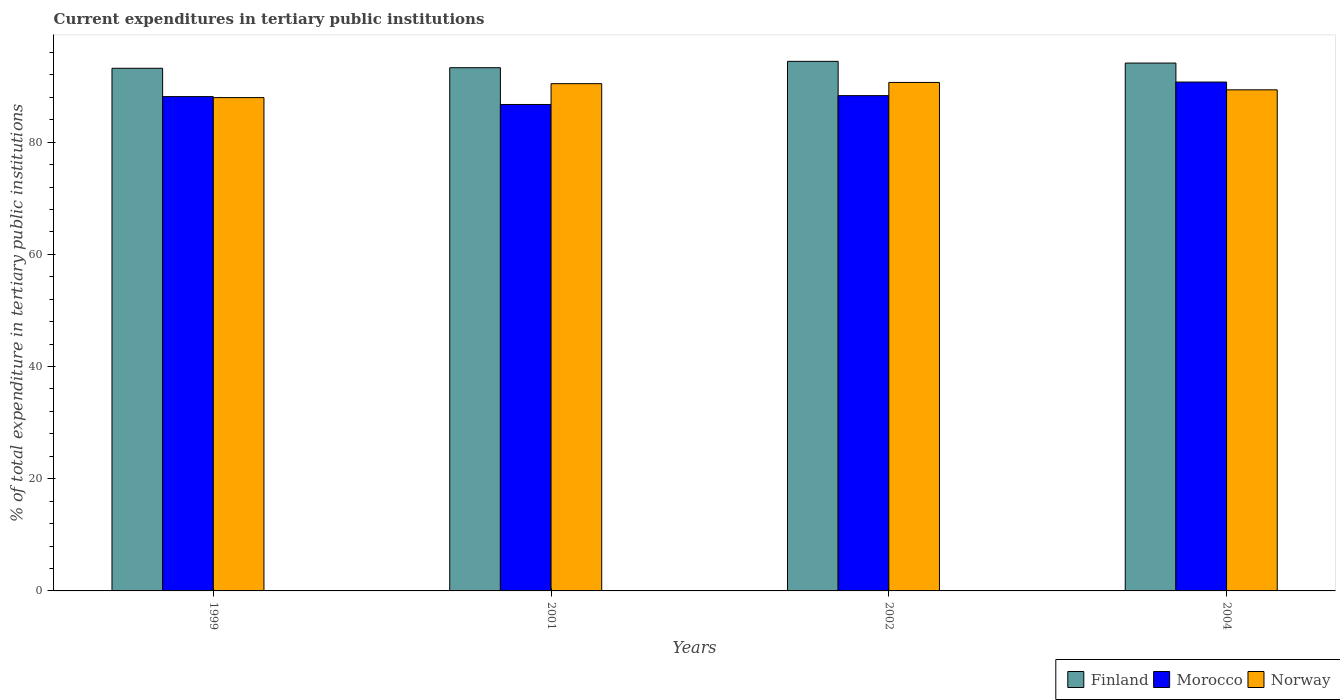How many different coloured bars are there?
Provide a succinct answer. 3. How many groups of bars are there?
Your answer should be compact. 4. Are the number of bars per tick equal to the number of legend labels?
Make the answer very short. Yes. How many bars are there on the 1st tick from the left?
Make the answer very short. 3. How many bars are there on the 2nd tick from the right?
Keep it short and to the point. 3. What is the label of the 2nd group of bars from the left?
Ensure brevity in your answer.  2001. What is the current expenditures in tertiary public institutions in Finland in 2002?
Provide a short and direct response. 94.4. Across all years, what is the maximum current expenditures in tertiary public institutions in Finland?
Ensure brevity in your answer.  94.4. Across all years, what is the minimum current expenditures in tertiary public institutions in Norway?
Provide a succinct answer. 87.94. In which year was the current expenditures in tertiary public institutions in Finland maximum?
Your answer should be very brief. 2002. What is the total current expenditures in tertiary public institutions in Finland in the graph?
Your answer should be very brief. 374.93. What is the difference between the current expenditures in tertiary public institutions in Finland in 1999 and that in 2004?
Provide a succinct answer. -0.93. What is the difference between the current expenditures in tertiary public institutions in Finland in 2002 and the current expenditures in tertiary public institutions in Norway in 1999?
Offer a very short reply. 6.46. What is the average current expenditures in tertiary public institutions in Finland per year?
Ensure brevity in your answer.  93.73. In the year 1999, what is the difference between the current expenditures in tertiary public institutions in Finland and current expenditures in tertiary public institutions in Morocco?
Provide a succinct answer. 5.05. What is the ratio of the current expenditures in tertiary public institutions in Finland in 2001 to that in 2004?
Provide a succinct answer. 0.99. Is the difference between the current expenditures in tertiary public institutions in Finland in 2002 and 2004 greater than the difference between the current expenditures in tertiary public institutions in Morocco in 2002 and 2004?
Offer a terse response. Yes. What is the difference between the highest and the second highest current expenditures in tertiary public institutions in Morocco?
Keep it short and to the point. 2.42. What is the difference between the highest and the lowest current expenditures in tertiary public institutions in Finland?
Your answer should be very brief. 1.23. Is the sum of the current expenditures in tertiary public institutions in Morocco in 1999 and 2001 greater than the maximum current expenditures in tertiary public institutions in Finland across all years?
Provide a short and direct response. Yes. Is it the case that in every year, the sum of the current expenditures in tertiary public institutions in Finland and current expenditures in tertiary public institutions in Norway is greater than the current expenditures in tertiary public institutions in Morocco?
Provide a short and direct response. Yes. How many bars are there?
Give a very brief answer. 12. Are all the bars in the graph horizontal?
Provide a succinct answer. No. What is the difference between two consecutive major ticks on the Y-axis?
Offer a terse response. 20. Are the values on the major ticks of Y-axis written in scientific E-notation?
Ensure brevity in your answer.  No. How many legend labels are there?
Provide a short and direct response. 3. What is the title of the graph?
Provide a short and direct response. Current expenditures in tertiary public institutions. What is the label or title of the X-axis?
Provide a succinct answer. Years. What is the label or title of the Y-axis?
Your answer should be very brief. % of total expenditure in tertiary public institutions. What is the % of total expenditure in tertiary public institutions of Finland in 1999?
Your answer should be compact. 93.17. What is the % of total expenditure in tertiary public institutions of Morocco in 1999?
Make the answer very short. 88.11. What is the % of total expenditure in tertiary public institutions of Norway in 1999?
Give a very brief answer. 87.94. What is the % of total expenditure in tertiary public institutions of Finland in 2001?
Provide a short and direct response. 93.27. What is the % of total expenditure in tertiary public institutions in Morocco in 2001?
Offer a terse response. 86.71. What is the % of total expenditure in tertiary public institutions of Norway in 2001?
Ensure brevity in your answer.  90.42. What is the % of total expenditure in tertiary public institutions in Finland in 2002?
Provide a short and direct response. 94.4. What is the % of total expenditure in tertiary public institutions of Morocco in 2002?
Offer a terse response. 88.29. What is the % of total expenditure in tertiary public institutions of Norway in 2002?
Your answer should be very brief. 90.64. What is the % of total expenditure in tertiary public institutions in Finland in 2004?
Your answer should be very brief. 94.09. What is the % of total expenditure in tertiary public institutions of Morocco in 2004?
Provide a succinct answer. 90.71. What is the % of total expenditure in tertiary public institutions of Norway in 2004?
Your response must be concise. 89.32. Across all years, what is the maximum % of total expenditure in tertiary public institutions of Finland?
Make the answer very short. 94.4. Across all years, what is the maximum % of total expenditure in tertiary public institutions of Morocco?
Keep it short and to the point. 90.71. Across all years, what is the maximum % of total expenditure in tertiary public institutions in Norway?
Your answer should be compact. 90.64. Across all years, what is the minimum % of total expenditure in tertiary public institutions in Finland?
Provide a succinct answer. 93.17. Across all years, what is the minimum % of total expenditure in tertiary public institutions of Morocco?
Your answer should be compact. 86.71. Across all years, what is the minimum % of total expenditure in tertiary public institutions of Norway?
Provide a short and direct response. 87.94. What is the total % of total expenditure in tertiary public institutions of Finland in the graph?
Your answer should be very brief. 374.93. What is the total % of total expenditure in tertiary public institutions of Morocco in the graph?
Your answer should be very brief. 353.83. What is the total % of total expenditure in tertiary public institutions of Norway in the graph?
Keep it short and to the point. 358.32. What is the difference between the % of total expenditure in tertiary public institutions of Finland in 1999 and that in 2001?
Offer a terse response. -0.1. What is the difference between the % of total expenditure in tertiary public institutions in Morocco in 1999 and that in 2001?
Your response must be concise. 1.4. What is the difference between the % of total expenditure in tertiary public institutions in Norway in 1999 and that in 2001?
Provide a short and direct response. -2.48. What is the difference between the % of total expenditure in tertiary public institutions of Finland in 1999 and that in 2002?
Your response must be concise. -1.23. What is the difference between the % of total expenditure in tertiary public institutions in Morocco in 1999 and that in 2002?
Offer a terse response. -0.17. What is the difference between the % of total expenditure in tertiary public institutions in Norway in 1999 and that in 2002?
Provide a succinct answer. -2.7. What is the difference between the % of total expenditure in tertiary public institutions of Finland in 1999 and that in 2004?
Offer a terse response. -0.93. What is the difference between the % of total expenditure in tertiary public institutions of Morocco in 1999 and that in 2004?
Give a very brief answer. -2.6. What is the difference between the % of total expenditure in tertiary public institutions in Norway in 1999 and that in 2004?
Make the answer very short. -1.38. What is the difference between the % of total expenditure in tertiary public institutions of Finland in 2001 and that in 2002?
Make the answer very short. -1.13. What is the difference between the % of total expenditure in tertiary public institutions of Morocco in 2001 and that in 2002?
Your response must be concise. -1.57. What is the difference between the % of total expenditure in tertiary public institutions in Norway in 2001 and that in 2002?
Your response must be concise. -0.22. What is the difference between the % of total expenditure in tertiary public institutions of Finland in 2001 and that in 2004?
Your answer should be compact. -0.83. What is the difference between the % of total expenditure in tertiary public institutions in Morocco in 2001 and that in 2004?
Provide a succinct answer. -4. What is the difference between the % of total expenditure in tertiary public institutions in Norway in 2001 and that in 2004?
Your response must be concise. 1.1. What is the difference between the % of total expenditure in tertiary public institutions of Finland in 2002 and that in 2004?
Keep it short and to the point. 0.31. What is the difference between the % of total expenditure in tertiary public institutions of Morocco in 2002 and that in 2004?
Provide a succinct answer. -2.42. What is the difference between the % of total expenditure in tertiary public institutions of Norway in 2002 and that in 2004?
Provide a short and direct response. 1.32. What is the difference between the % of total expenditure in tertiary public institutions in Finland in 1999 and the % of total expenditure in tertiary public institutions in Morocco in 2001?
Provide a succinct answer. 6.45. What is the difference between the % of total expenditure in tertiary public institutions in Finland in 1999 and the % of total expenditure in tertiary public institutions in Norway in 2001?
Make the answer very short. 2.74. What is the difference between the % of total expenditure in tertiary public institutions in Morocco in 1999 and the % of total expenditure in tertiary public institutions in Norway in 2001?
Your answer should be compact. -2.31. What is the difference between the % of total expenditure in tertiary public institutions in Finland in 1999 and the % of total expenditure in tertiary public institutions in Morocco in 2002?
Offer a terse response. 4.88. What is the difference between the % of total expenditure in tertiary public institutions of Finland in 1999 and the % of total expenditure in tertiary public institutions of Norway in 2002?
Offer a very short reply. 2.52. What is the difference between the % of total expenditure in tertiary public institutions in Morocco in 1999 and the % of total expenditure in tertiary public institutions in Norway in 2002?
Offer a very short reply. -2.53. What is the difference between the % of total expenditure in tertiary public institutions of Finland in 1999 and the % of total expenditure in tertiary public institutions of Morocco in 2004?
Provide a succinct answer. 2.46. What is the difference between the % of total expenditure in tertiary public institutions of Finland in 1999 and the % of total expenditure in tertiary public institutions of Norway in 2004?
Your answer should be compact. 3.84. What is the difference between the % of total expenditure in tertiary public institutions of Morocco in 1999 and the % of total expenditure in tertiary public institutions of Norway in 2004?
Give a very brief answer. -1.21. What is the difference between the % of total expenditure in tertiary public institutions of Finland in 2001 and the % of total expenditure in tertiary public institutions of Morocco in 2002?
Keep it short and to the point. 4.98. What is the difference between the % of total expenditure in tertiary public institutions in Finland in 2001 and the % of total expenditure in tertiary public institutions in Norway in 2002?
Provide a succinct answer. 2.63. What is the difference between the % of total expenditure in tertiary public institutions of Morocco in 2001 and the % of total expenditure in tertiary public institutions of Norway in 2002?
Give a very brief answer. -3.93. What is the difference between the % of total expenditure in tertiary public institutions of Finland in 2001 and the % of total expenditure in tertiary public institutions of Morocco in 2004?
Ensure brevity in your answer.  2.56. What is the difference between the % of total expenditure in tertiary public institutions in Finland in 2001 and the % of total expenditure in tertiary public institutions in Norway in 2004?
Your answer should be very brief. 3.94. What is the difference between the % of total expenditure in tertiary public institutions in Morocco in 2001 and the % of total expenditure in tertiary public institutions in Norway in 2004?
Provide a short and direct response. -2.61. What is the difference between the % of total expenditure in tertiary public institutions in Finland in 2002 and the % of total expenditure in tertiary public institutions in Morocco in 2004?
Your response must be concise. 3.69. What is the difference between the % of total expenditure in tertiary public institutions of Finland in 2002 and the % of total expenditure in tertiary public institutions of Norway in 2004?
Your response must be concise. 5.08. What is the difference between the % of total expenditure in tertiary public institutions in Morocco in 2002 and the % of total expenditure in tertiary public institutions in Norway in 2004?
Your answer should be very brief. -1.03. What is the average % of total expenditure in tertiary public institutions of Finland per year?
Your answer should be compact. 93.73. What is the average % of total expenditure in tertiary public institutions of Morocco per year?
Ensure brevity in your answer.  88.46. What is the average % of total expenditure in tertiary public institutions of Norway per year?
Provide a short and direct response. 89.58. In the year 1999, what is the difference between the % of total expenditure in tertiary public institutions of Finland and % of total expenditure in tertiary public institutions of Morocco?
Your answer should be very brief. 5.05. In the year 1999, what is the difference between the % of total expenditure in tertiary public institutions of Finland and % of total expenditure in tertiary public institutions of Norway?
Your answer should be compact. 5.23. In the year 1999, what is the difference between the % of total expenditure in tertiary public institutions of Morocco and % of total expenditure in tertiary public institutions of Norway?
Your answer should be compact. 0.18. In the year 2001, what is the difference between the % of total expenditure in tertiary public institutions of Finland and % of total expenditure in tertiary public institutions of Morocco?
Offer a very short reply. 6.55. In the year 2001, what is the difference between the % of total expenditure in tertiary public institutions in Finland and % of total expenditure in tertiary public institutions in Norway?
Keep it short and to the point. 2.85. In the year 2001, what is the difference between the % of total expenditure in tertiary public institutions of Morocco and % of total expenditure in tertiary public institutions of Norway?
Give a very brief answer. -3.71. In the year 2002, what is the difference between the % of total expenditure in tertiary public institutions of Finland and % of total expenditure in tertiary public institutions of Morocco?
Give a very brief answer. 6.11. In the year 2002, what is the difference between the % of total expenditure in tertiary public institutions in Finland and % of total expenditure in tertiary public institutions in Norway?
Your answer should be compact. 3.76. In the year 2002, what is the difference between the % of total expenditure in tertiary public institutions of Morocco and % of total expenditure in tertiary public institutions of Norway?
Keep it short and to the point. -2.35. In the year 2004, what is the difference between the % of total expenditure in tertiary public institutions of Finland and % of total expenditure in tertiary public institutions of Morocco?
Provide a short and direct response. 3.39. In the year 2004, what is the difference between the % of total expenditure in tertiary public institutions of Finland and % of total expenditure in tertiary public institutions of Norway?
Provide a succinct answer. 4.77. In the year 2004, what is the difference between the % of total expenditure in tertiary public institutions of Morocco and % of total expenditure in tertiary public institutions of Norway?
Ensure brevity in your answer.  1.39. What is the ratio of the % of total expenditure in tertiary public institutions in Finland in 1999 to that in 2001?
Offer a very short reply. 1. What is the ratio of the % of total expenditure in tertiary public institutions of Morocco in 1999 to that in 2001?
Give a very brief answer. 1.02. What is the ratio of the % of total expenditure in tertiary public institutions in Norway in 1999 to that in 2001?
Make the answer very short. 0.97. What is the ratio of the % of total expenditure in tertiary public institutions of Finland in 1999 to that in 2002?
Ensure brevity in your answer.  0.99. What is the ratio of the % of total expenditure in tertiary public institutions in Morocco in 1999 to that in 2002?
Your answer should be compact. 1. What is the ratio of the % of total expenditure in tertiary public institutions in Norway in 1999 to that in 2002?
Provide a succinct answer. 0.97. What is the ratio of the % of total expenditure in tertiary public institutions of Finland in 1999 to that in 2004?
Provide a short and direct response. 0.99. What is the ratio of the % of total expenditure in tertiary public institutions of Morocco in 1999 to that in 2004?
Provide a short and direct response. 0.97. What is the ratio of the % of total expenditure in tertiary public institutions of Norway in 1999 to that in 2004?
Give a very brief answer. 0.98. What is the ratio of the % of total expenditure in tertiary public institutions in Morocco in 2001 to that in 2002?
Provide a succinct answer. 0.98. What is the ratio of the % of total expenditure in tertiary public institutions of Norway in 2001 to that in 2002?
Give a very brief answer. 1. What is the ratio of the % of total expenditure in tertiary public institutions in Finland in 2001 to that in 2004?
Your answer should be very brief. 0.99. What is the ratio of the % of total expenditure in tertiary public institutions in Morocco in 2001 to that in 2004?
Offer a terse response. 0.96. What is the ratio of the % of total expenditure in tertiary public institutions of Norway in 2001 to that in 2004?
Provide a succinct answer. 1.01. What is the ratio of the % of total expenditure in tertiary public institutions in Morocco in 2002 to that in 2004?
Provide a succinct answer. 0.97. What is the ratio of the % of total expenditure in tertiary public institutions in Norway in 2002 to that in 2004?
Keep it short and to the point. 1.01. What is the difference between the highest and the second highest % of total expenditure in tertiary public institutions in Finland?
Offer a terse response. 0.31. What is the difference between the highest and the second highest % of total expenditure in tertiary public institutions in Morocco?
Give a very brief answer. 2.42. What is the difference between the highest and the second highest % of total expenditure in tertiary public institutions of Norway?
Your answer should be compact. 0.22. What is the difference between the highest and the lowest % of total expenditure in tertiary public institutions of Finland?
Your answer should be very brief. 1.23. What is the difference between the highest and the lowest % of total expenditure in tertiary public institutions of Morocco?
Provide a succinct answer. 4. What is the difference between the highest and the lowest % of total expenditure in tertiary public institutions in Norway?
Give a very brief answer. 2.7. 